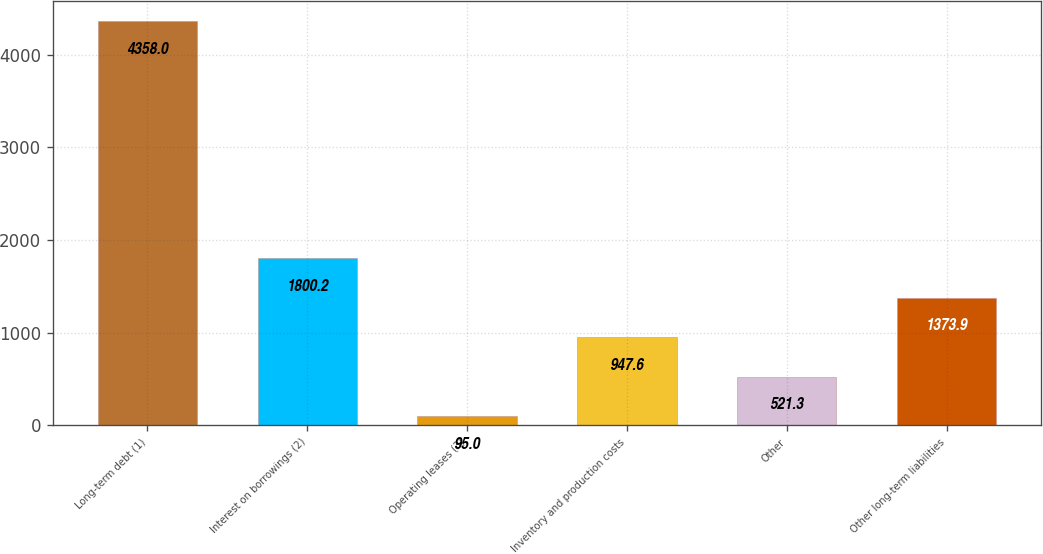Convert chart to OTSL. <chart><loc_0><loc_0><loc_500><loc_500><bar_chart><fcel>Long-term debt (1)<fcel>Interest on borrowings (2)<fcel>Operating leases (3)<fcel>Inventory and production costs<fcel>Other<fcel>Other long-term liabilities<nl><fcel>4358<fcel>1800.2<fcel>95<fcel>947.6<fcel>521.3<fcel>1373.9<nl></chart> 